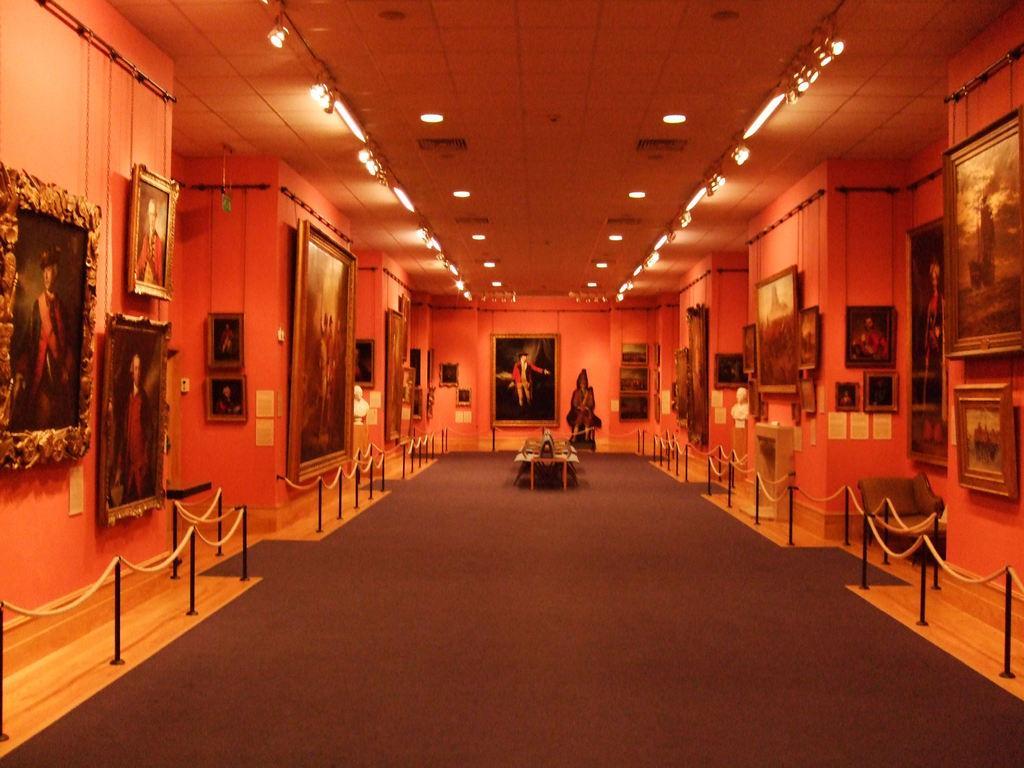In one or two sentences, can you explain what this image depicts? On either side of the picture, we see the barrier poles and walls on which photo frames are placed. In the middle of the picture, we see a table. At the bottom, we see a carpet. There are many photo frames and charts placed on the wall. At the top, we see the ceiling of the room. 